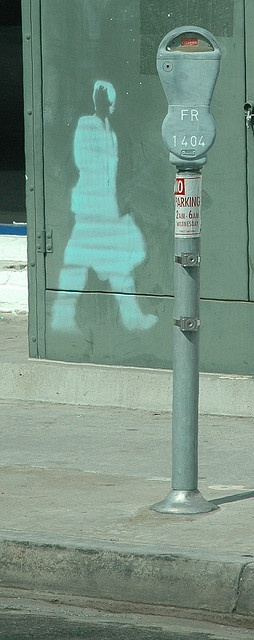Describe the objects in this image and their specific colors. I can see a parking meter in black, darkgray, teal, and gray tones in this image. 